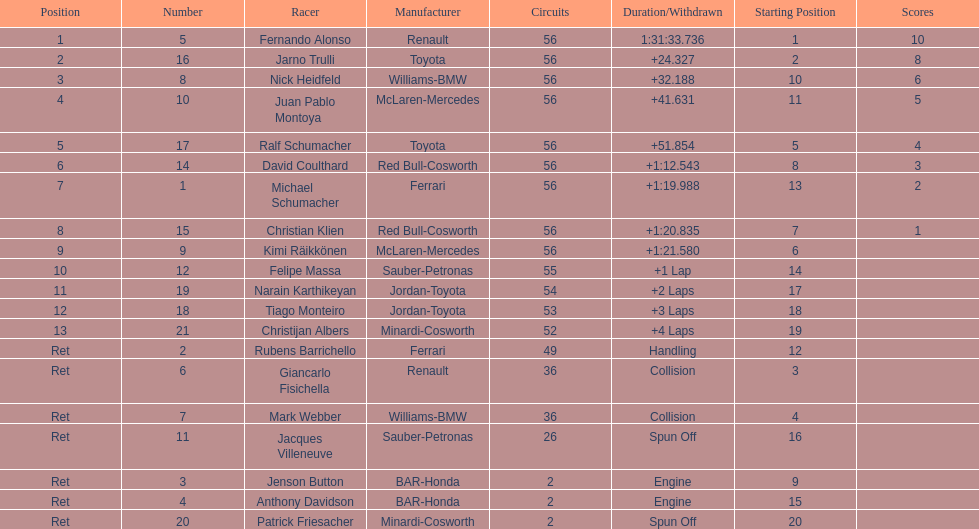Who was the last driver to actually finish the race? Christijan Albers. Parse the table in full. {'header': ['Position', 'Number', 'Racer', 'Manufacturer', 'Circuits', 'Duration/Withdrawn', 'Starting Position', 'Scores'], 'rows': [['1', '5', 'Fernando Alonso', 'Renault', '56', '1:31:33.736', '1', '10'], ['2', '16', 'Jarno Trulli', 'Toyota', '56', '+24.327', '2', '8'], ['3', '8', 'Nick Heidfeld', 'Williams-BMW', '56', '+32.188', '10', '6'], ['4', '10', 'Juan Pablo Montoya', 'McLaren-Mercedes', '56', '+41.631', '11', '5'], ['5', '17', 'Ralf Schumacher', 'Toyota', '56', '+51.854', '5', '4'], ['6', '14', 'David Coulthard', 'Red Bull-Cosworth', '56', '+1:12.543', '8', '3'], ['7', '1', 'Michael Schumacher', 'Ferrari', '56', '+1:19.988', '13', '2'], ['8', '15', 'Christian Klien', 'Red Bull-Cosworth', '56', '+1:20.835', '7', '1'], ['9', '9', 'Kimi Räikkönen', 'McLaren-Mercedes', '56', '+1:21.580', '6', ''], ['10', '12', 'Felipe Massa', 'Sauber-Petronas', '55', '+1 Lap', '14', ''], ['11', '19', 'Narain Karthikeyan', 'Jordan-Toyota', '54', '+2 Laps', '17', ''], ['12', '18', 'Tiago Monteiro', 'Jordan-Toyota', '53', '+3 Laps', '18', ''], ['13', '21', 'Christijan Albers', 'Minardi-Cosworth', '52', '+4 Laps', '19', ''], ['Ret', '2', 'Rubens Barrichello', 'Ferrari', '49', 'Handling', '12', ''], ['Ret', '6', 'Giancarlo Fisichella', 'Renault', '36', 'Collision', '3', ''], ['Ret', '7', 'Mark Webber', 'Williams-BMW', '36', 'Collision', '4', ''], ['Ret', '11', 'Jacques Villeneuve', 'Sauber-Petronas', '26', 'Spun Off', '16', ''], ['Ret', '3', 'Jenson Button', 'BAR-Honda', '2', 'Engine', '9', ''], ['Ret', '4', 'Anthony Davidson', 'BAR-Honda', '2', 'Engine', '15', ''], ['Ret', '20', 'Patrick Friesacher', 'Minardi-Cosworth', '2', 'Spun Off', '20', '']]} 